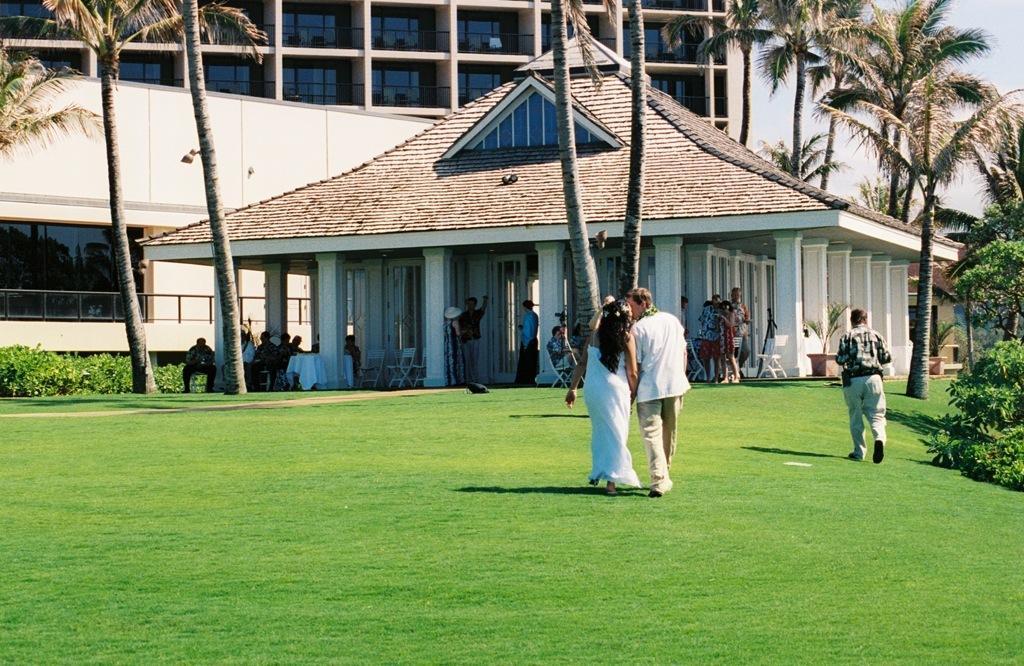In one or two sentences, can you explain what this image depicts? In this picture I can see a man and a woman standing, there are group of people standing, there are group of people sitting on the chairs, there is a table, there are plants, trees, there are buildings, and in the background there is the sky. 